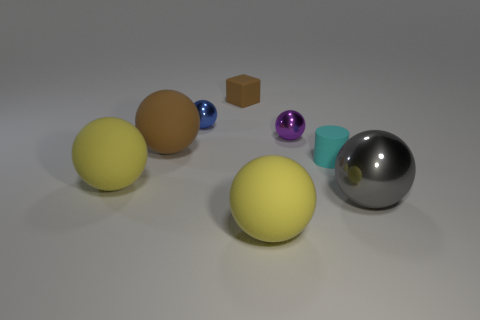Subtract 1 balls. How many balls are left? 5 Subtract all gray shiny spheres. How many spheres are left? 5 Subtract all blue balls. How many balls are left? 5 Add 2 purple objects. How many objects exist? 10 Subtract all brown spheres. Subtract all purple blocks. How many spheres are left? 5 Subtract all cylinders. How many objects are left? 7 Add 1 tiny cylinders. How many tiny cylinders exist? 2 Subtract 0 green blocks. How many objects are left? 8 Subtract all small metal objects. Subtract all gray balls. How many objects are left? 5 Add 3 big balls. How many big balls are left? 7 